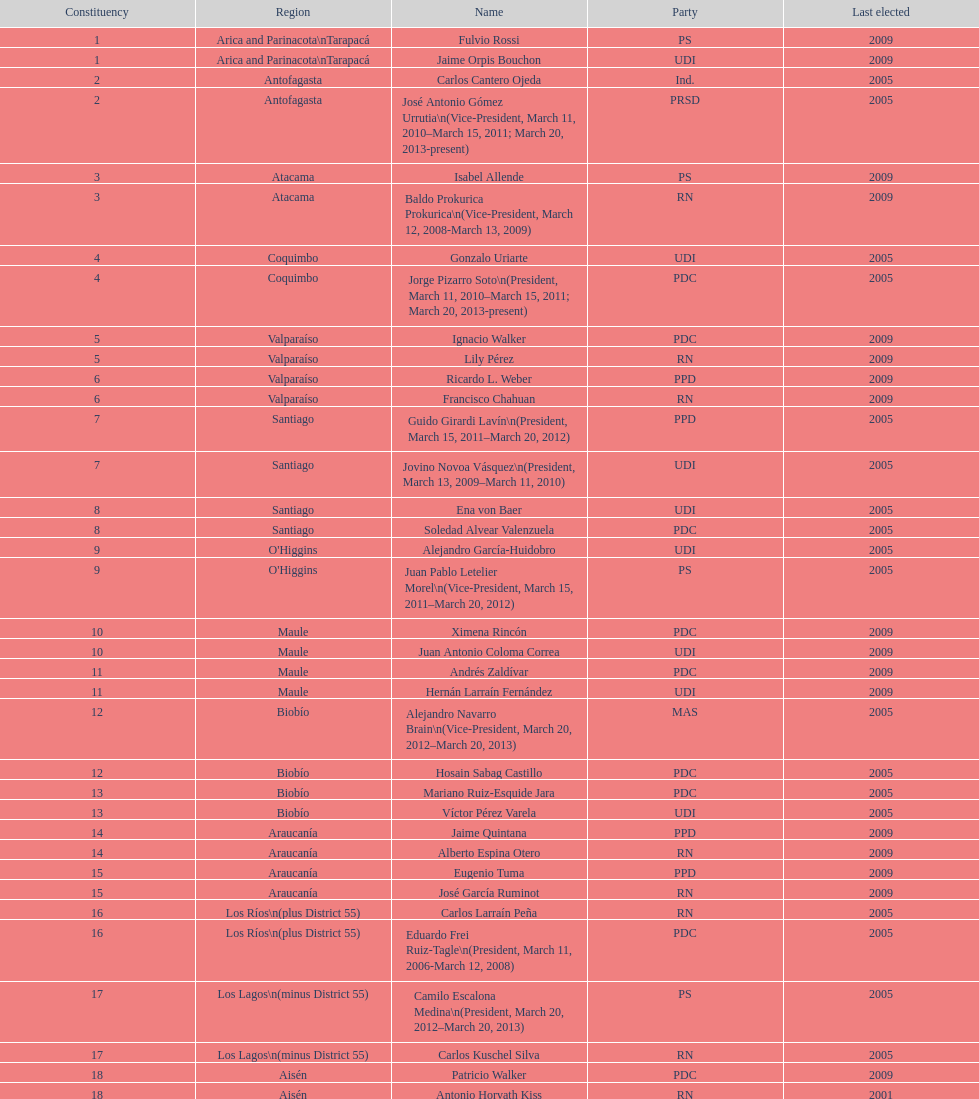When was antonio horvath kiss last chosen? 2001. 